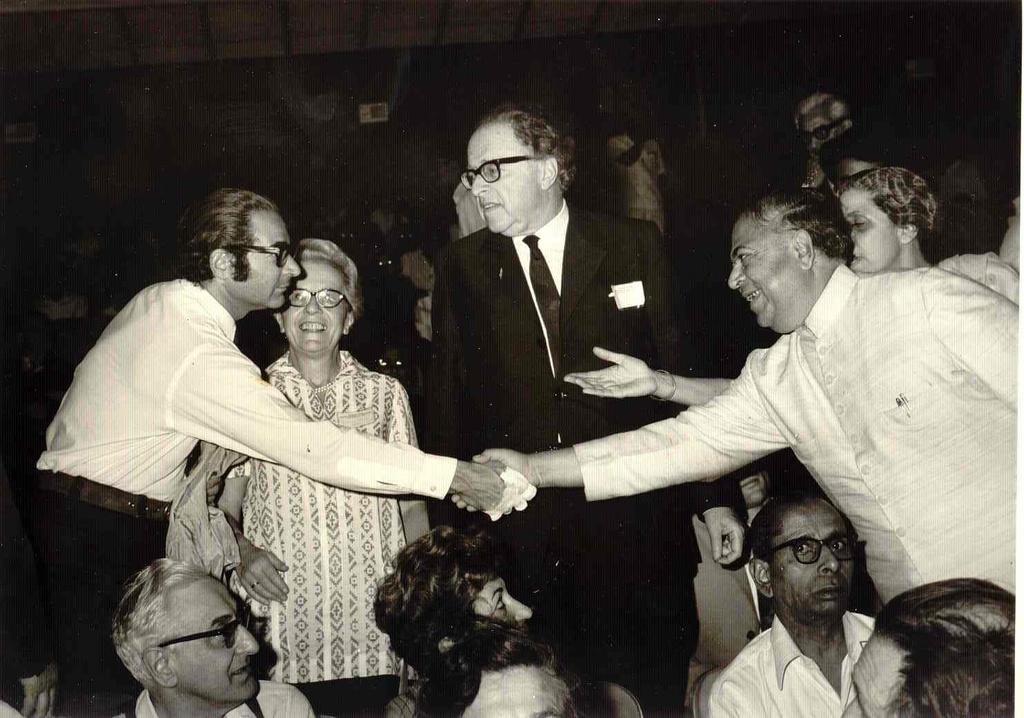In one or two sentences, can you explain what this image depicts? In this image we can see black and white picture of a group of people standing and some people are sitting on chairs. 